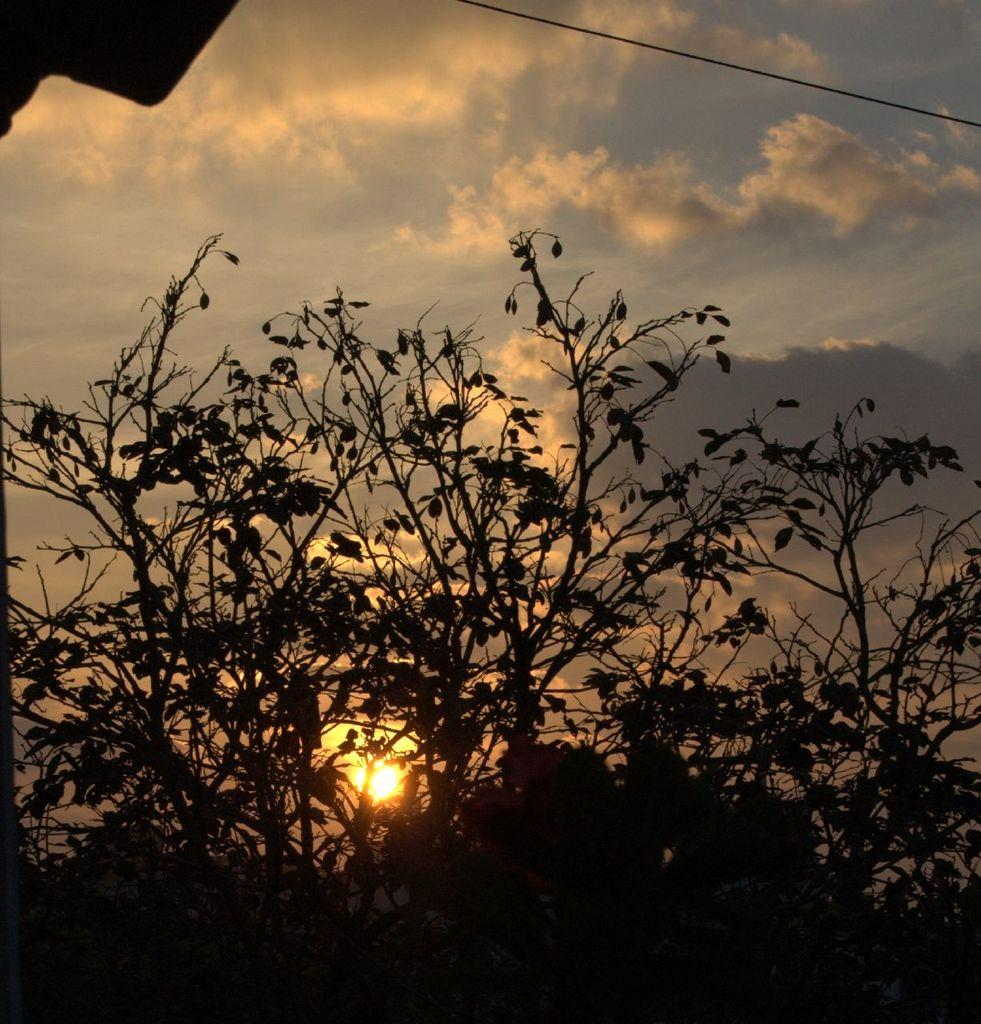What type of vegetation can be seen in the image? There are trees in the image. What can be seen in the sky in the image? There are clouds and the sun visible in the sky. What type of pot is being used to learn under the trees in the image? There is no pot or learning activity depicted in the image; it only features trees and a sky with clouds and the sun. Is there an umbrella visible in the image? No, there is no umbrella present in the image. 